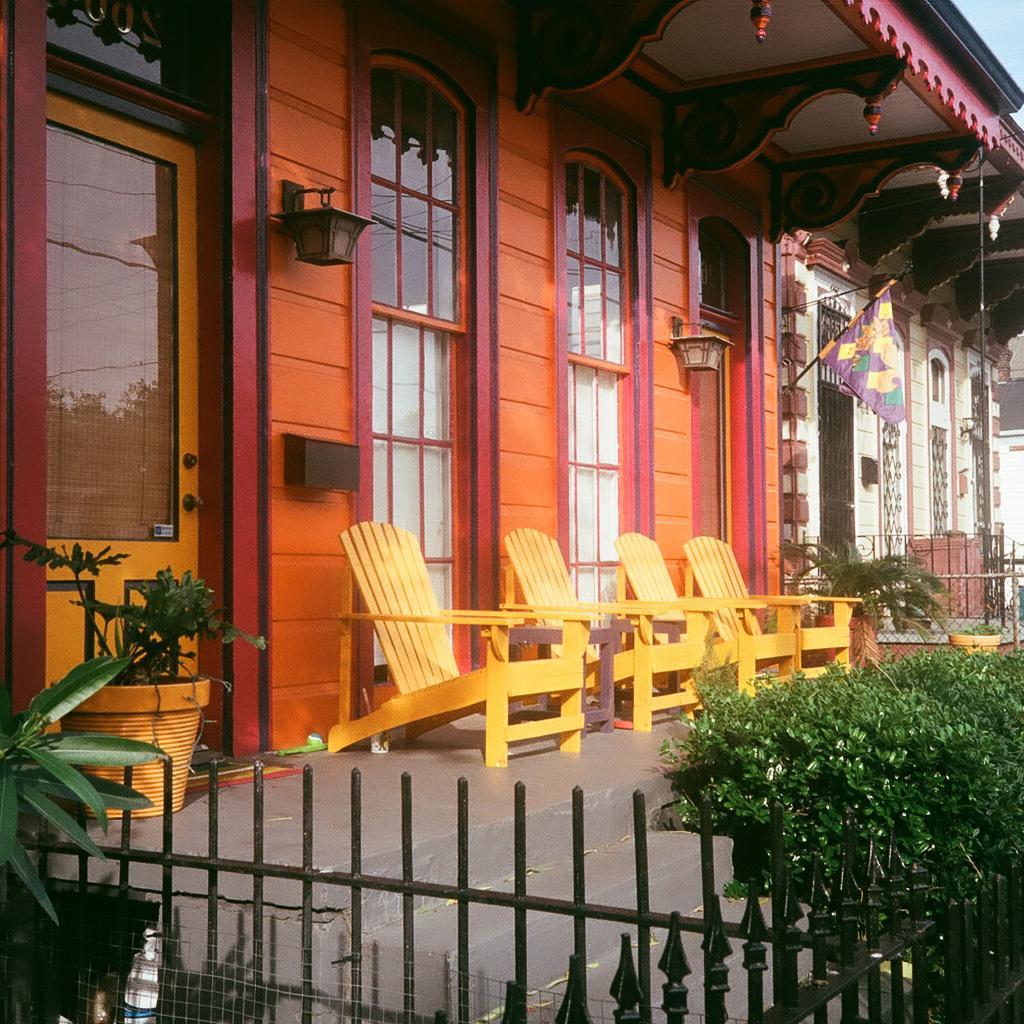Please provide a concise description of this image. In the picture we can see a building wall with a door and windows with glasses in it and near it, we can see some chairs which are yellow in color and near to it, we can see a railing and some plants near it and into the wall we can also see some flag and a lamb to the wall. 